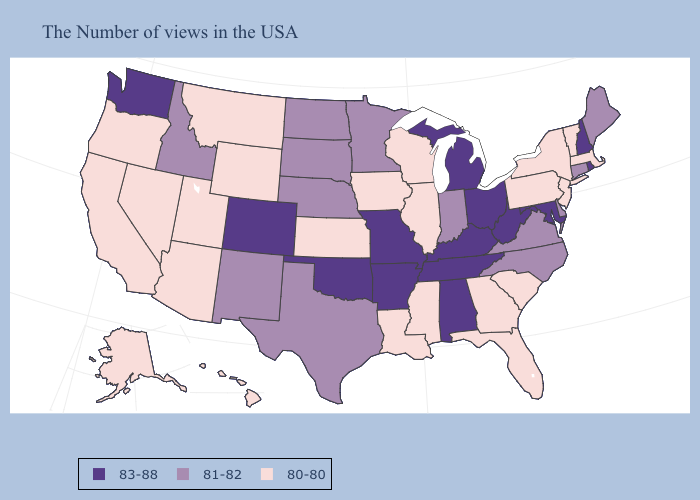Does Massachusetts have the highest value in the USA?
Give a very brief answer. No. Does West Virginia have the lowest value in the South?
Quick response, please. No. Name the states that have a value in the range 81-82?
Quick response, please. Maine, Connecticut, Delaware, Virginia, North Carolina, Indiana, Minnesota, Nebraska, Texas, South Dakota, North Dakota, New Mexico, Idaho. Which states have the highest value in the USA?
Answer briefly. Rhode Island, New Hampshire, Maryland, West Virginia, Ohio, Michigan, Kentucky, Alabama, Tennessee, Missouri, Arkansas, Oklahoma, Colorado, Washington. Which states have the lowest value in the West?
Write a very short answer. Wyoming, Utah, Montana, Arizona, Nevada, California, Oregon, Alaska, Hawaii. Does Virginia have a lower value than New York?
Short answer required. No. Name the states that have a value in the range 81-82?
Write a very short answer. Maine, Connecticut, Delaware, Virginia, North Carolina, Indiana, Minnesota, Nebraska, Texas, South Dakota, North Dakota, New Mexico, Idaho. What is the lowest value in states that border Texas?
Concise answer only. 80-80. Name the states that have a value in the range 80-80?
Short answer required. Massachusetts, Vermont, New York, New Jersey, Pennsylvania, South Carolina, Florida, Georgia, Wisconsin, Illinois, Mississippi, Louisiana, Iowa, Kansas, Wyoming, Utah, Montana, Arizona, Nevada, California, Oregon, Alaska, Hawaii. What is the lowest value in the South?
Be succinct. 80-80. What is the value of Alabama?
Keep it brief. 83-88. Among the states that border Michigan , does Indiana have the highest value?
Short answer required. No. Does Mississippi have the highest value in the USA?
Answer briefly. No. What is the value of South Carolina?
Write a very short answer. 80-80. Does Michigan have a higher value than Alabama?
Answer briefly. No. 